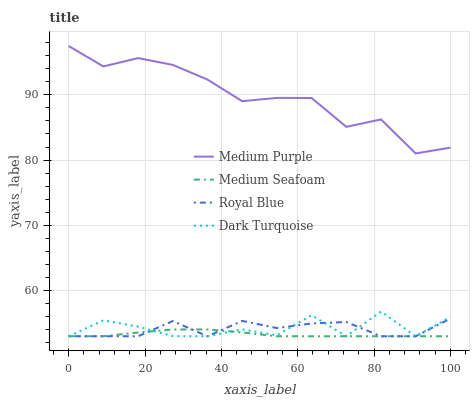Does Medium Seafoam have the minimum area under the curve?
Answer yes or no. Yes. Does Royal Blue have the minimum area under the curve?
Answer yes or no. No. Does Royal Blue have the maximum area under the curve?
Answer yes or no. No. Is Dark Turquoise the roughest?
Answer yes or no. Yes. Is Royal Blue the smoothest?
Answer yes or no. No. Is Royal Blue the roughest?
Answer yes or no. No. Does Royal Blue have the highest value?
Answer yes or no. No. Is Dark Turquoise less than Medium Purple?
Answer yes or no. Yes. Is Medium Purple greater than Medium Seafoam?
Answer yes or no. Yes. Does Dark Turquoise intersect Medium Purple?
Answer yes or no. No. 